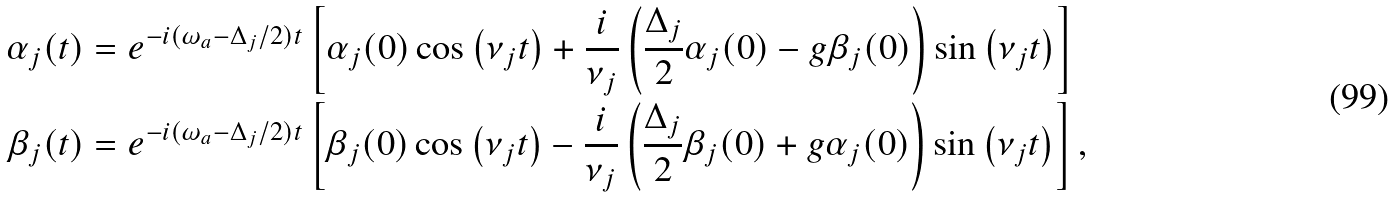<formula> <loc_0><loc_0><loc_500><loc_500>\alpha _ { j } ( t ) & = e ^ { - i ( \omega _ { a } - \Delta _ { j } / 2 ) t } \left [ \alpha _ { j } ( 0 ) \cos \left ( \nu _ { j } t \right ) + \frac { i } { \nu _ { j } } \left ( \frac { \Delta _ { j } } { 2 } \alpha _ { j } ( 0 ) - g \beta _ { j } ( 0 ) \right ) \sin \left ( \nu _ { j } t \right ) \right ] \\ \beta _ { j } ( t ) & = e ^ { - i ( \omega _ { a } - \Delta _ { j } / 2 ) t } \left [ \beta _ { j } ( 0 ) \cos \left ( \nu _ { j } t \right ) - \frac { i } { \nu _ { j } } \left ( \frac { \Delta _ { j } } { 2 } \beta _ { j } ( 0 ) + g \alpha _ { j } ( 0 ) \right ) \sin \left ( \nu _ { j } t \right ) \right ] ,</formula> 